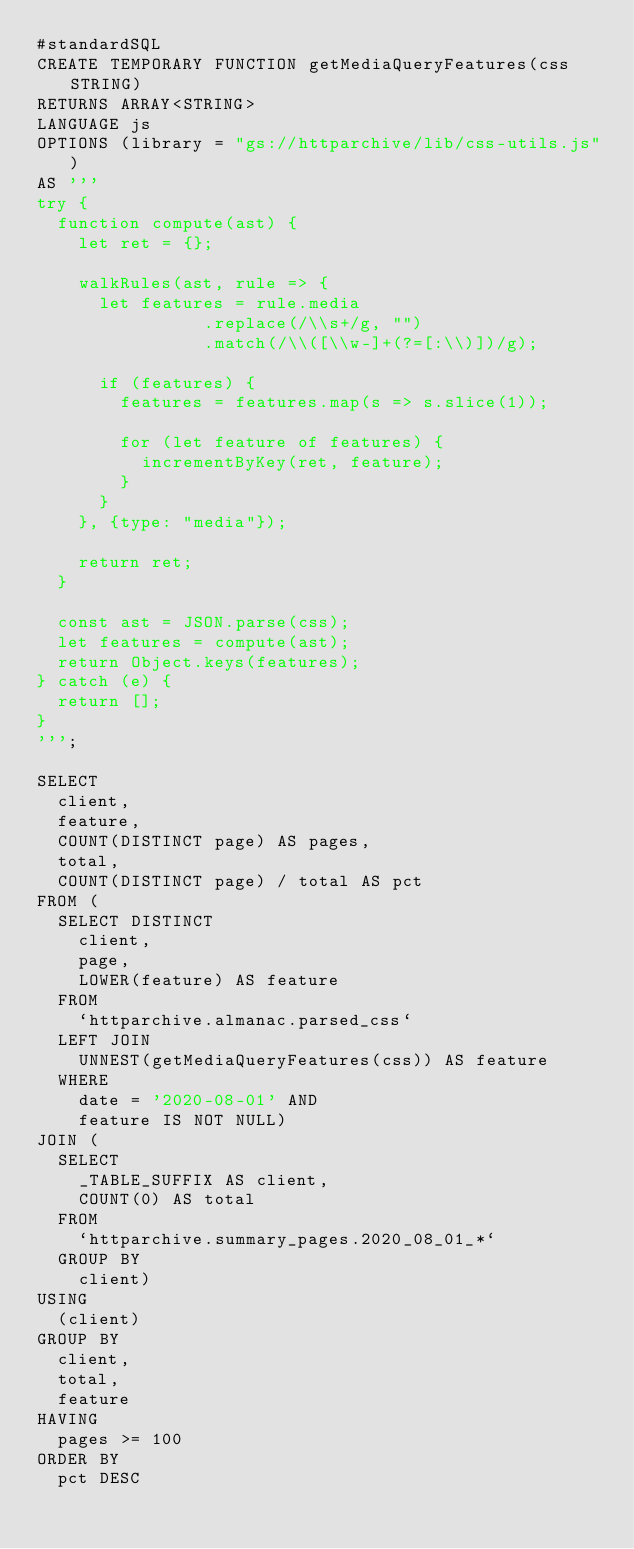<code> <loc_0><loc_0><loc_500><loc_500><_SQL_>#standardSQL
CREATE TEMPORARY FUNCTION getMediaQueryFeatures(css STRING)
RETURNS ARRAY<STRING>
LANGUAGE js
OPTIONS (library = "gs://httparchive/lib/css-utils.js")
AS '''
try {
  function compute(ast) {
    let ret = {};

    walkRules(ast, rule => {
      let features = rule.media
                .replace(/\\s+/g, "")
                .match(/\\([\\w-]+(?=[:\\)])/g);

      if (features) {
        features = features.map(s => s.slice(1));

        for (let feature of features) {
          incrementByKey(ret, feature);
        }
      }
    }, {type: "media"});

    return ret;
  }

  const ast = JSON.parse(css);
  let features = compute(ast);
  return Object.keys(features);
} catch (e) {
  return [];
}
''';

SELECT
  client,
  feature,
  COUNT(DISTINCT page) AS pages,
  total,
  COUNT(DISTINCT page) / total AS pct
FROM (
  SELECT DISTINCT
    client,
    page,
    LOWER(feature) AS feature
  FROM
    `httparchive.almanac.parsed_css`
  LEFT JOIN
    UNNEST(getMediaQueryFeatures(css)) AS feature
  WHERE
    date = '2020-08-01' AND
    feature IS NOT NULL)
JOIN (
  SELECT
    _TABLE_SUFFIX AS client,
    COUNT(0) AS total
  FROM
    `httparchive.summary_pages.2020_08_01_*`
  GROUP BY
    client)
USING
  (client)
GROUP BY
  client,
  total,
  feature
HAVING
  pages >= 100
ORDER BY
  pct DESC
</code> 